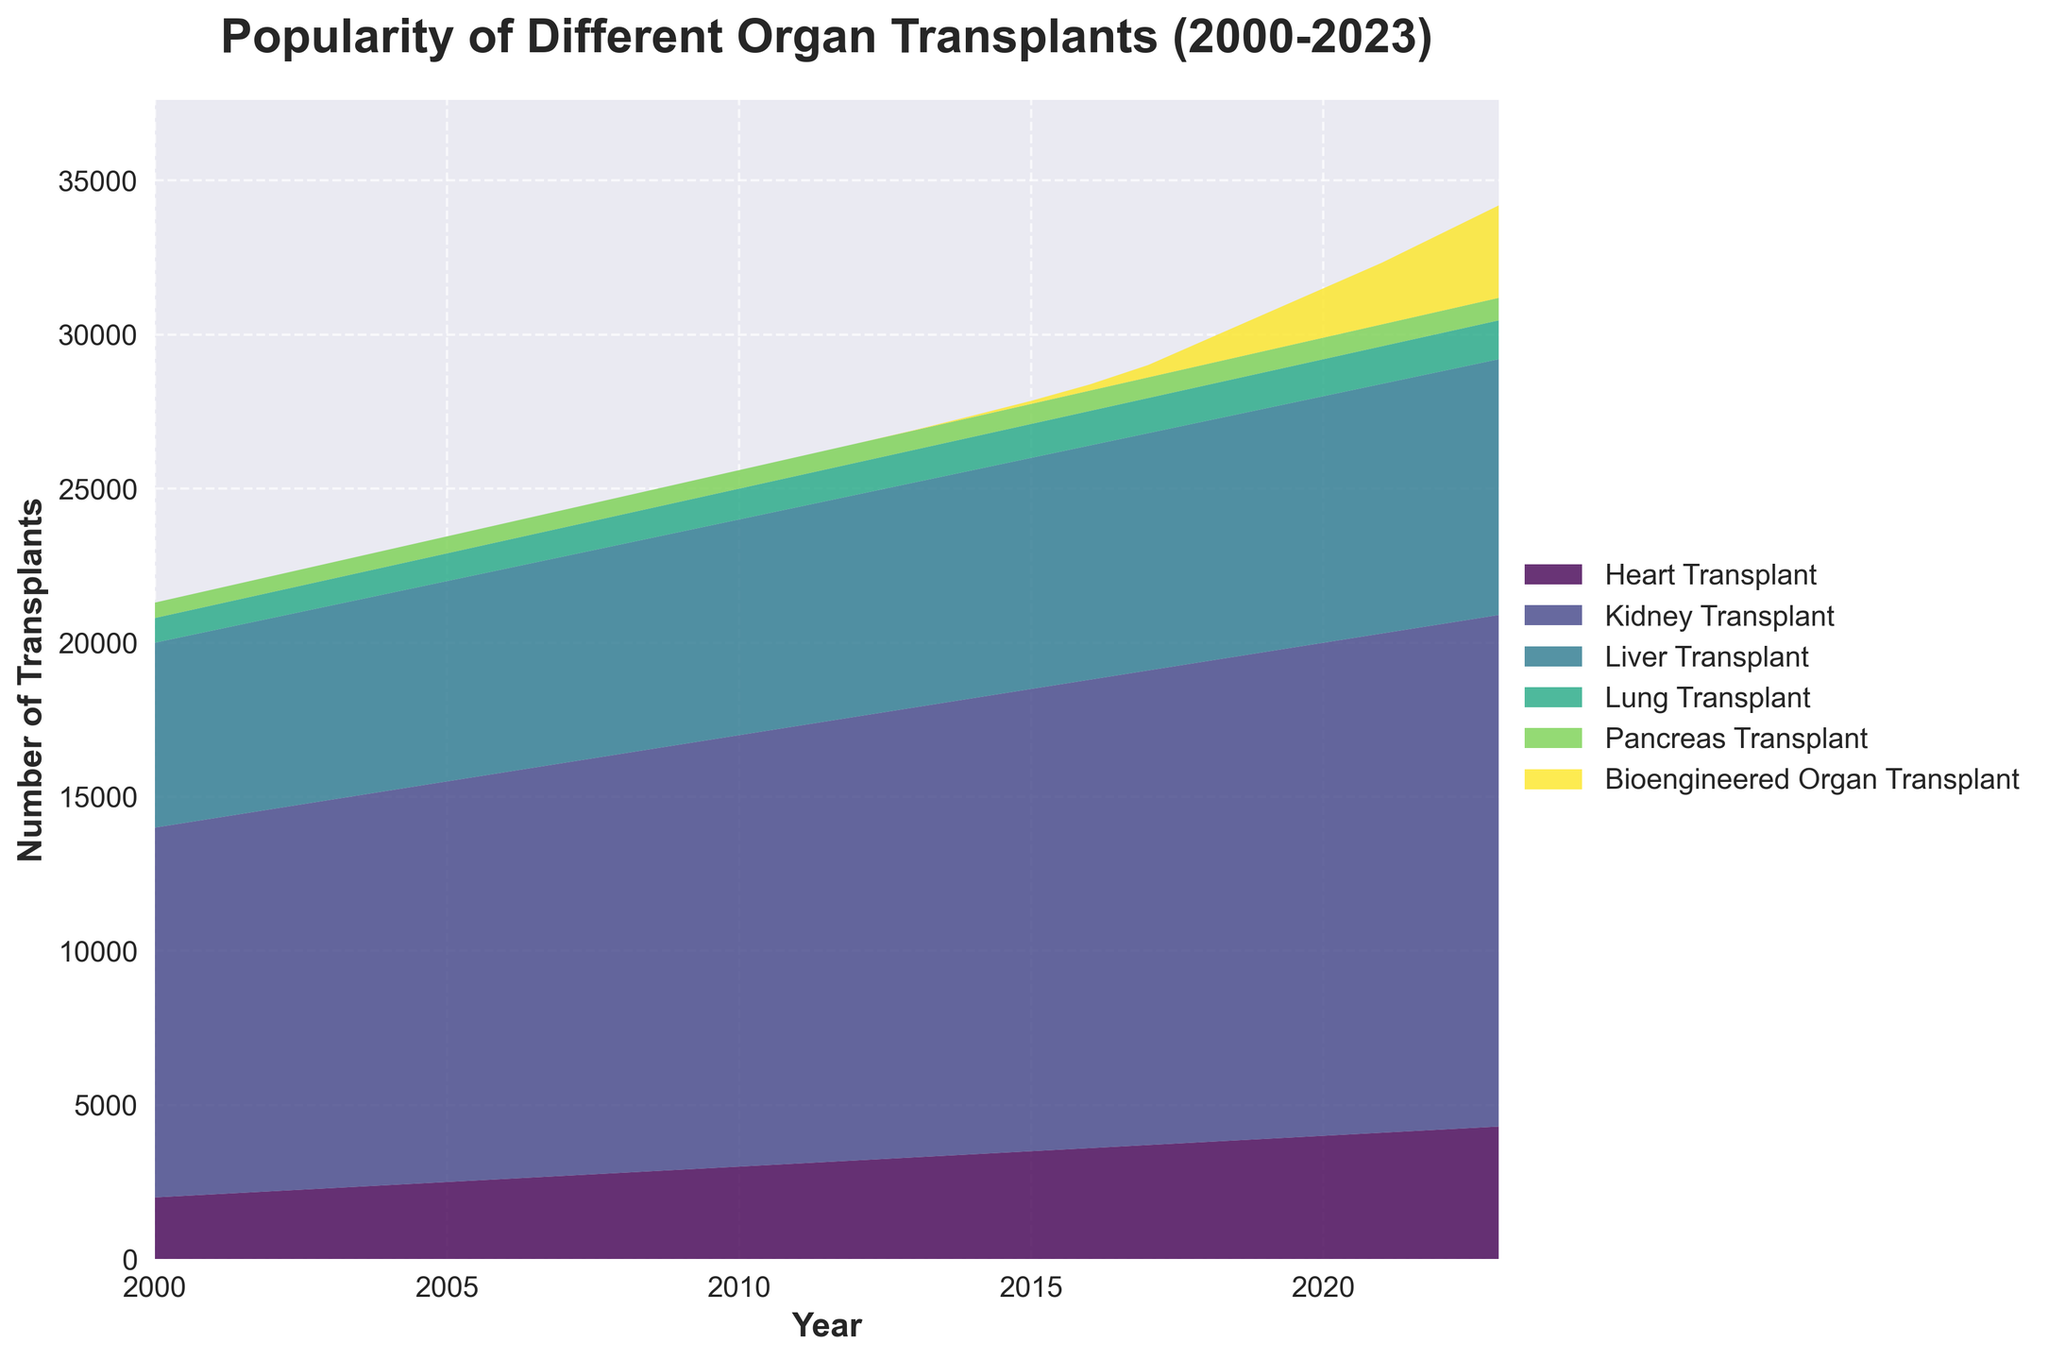What is the title of the figure? The title is located at the top of the figure. It reads "Popularity of Different Organ Transplants (2000-2023)".
Answer: Popularity of Different Organ Transplants (2000-2023) What are the years displayed on the x-axis? The x-axis displays years from 2000 to 2023, marked at regular intervals.
Answer: 2000 to 2023 Which organ transplant type shows up last in the legend? By looking at the legend on the right side of the plot, the last entry is "Bioengineered Organ Transplant".
Answer: Bioengineered Organ Transplant Which transplant had no instances in 2000? From the data, the "Bioengineered Organ Transplant" had 0 occurrences in 2000.
Answer: Bioengineered Organ Transplant How many types of transplants are represented in the figure? By counting the distinct labels in the legend, there are six different types of transplants represented.
Answer: 6 In which year did bioengineered organ transplants first appear? Observing the area chart, "Bioengineered Organ Transplant" first shows a noticeable area around 2013.
Answer: 2013 Approximately how many kidney transplants were performed in 2010? Referring to the specific color section of the kidney transplants in 2010 on the stack plot, it appears to be at the 14000 mark.
Answer: 14000 What is the general trend of liver transplants from 2000 to 2023? By examining the chart, the area corresponding to "Liver Transplant" increases steadily over the years from 2000 to 2023.
Answer: Increasing Compare the number of lung transplants to pancreas transplants in 2015. Which was higher? In 2015, by viewing the chart, the area for "Lung Transplant" is larger than that for "Pancreas Transplant", indicating that lung transplants were higher.
Answer: Lung Transplants What's the total number of transplants in 2005? To find the total, add the values for all transplants in 2005: 2500 (Heart) + 13000 (Kidney) + 6500 (Liver) + 900 (Lung) + 550 (Pancreas) + 0 (Bioengineered) = 23450.
Answer: 23450 